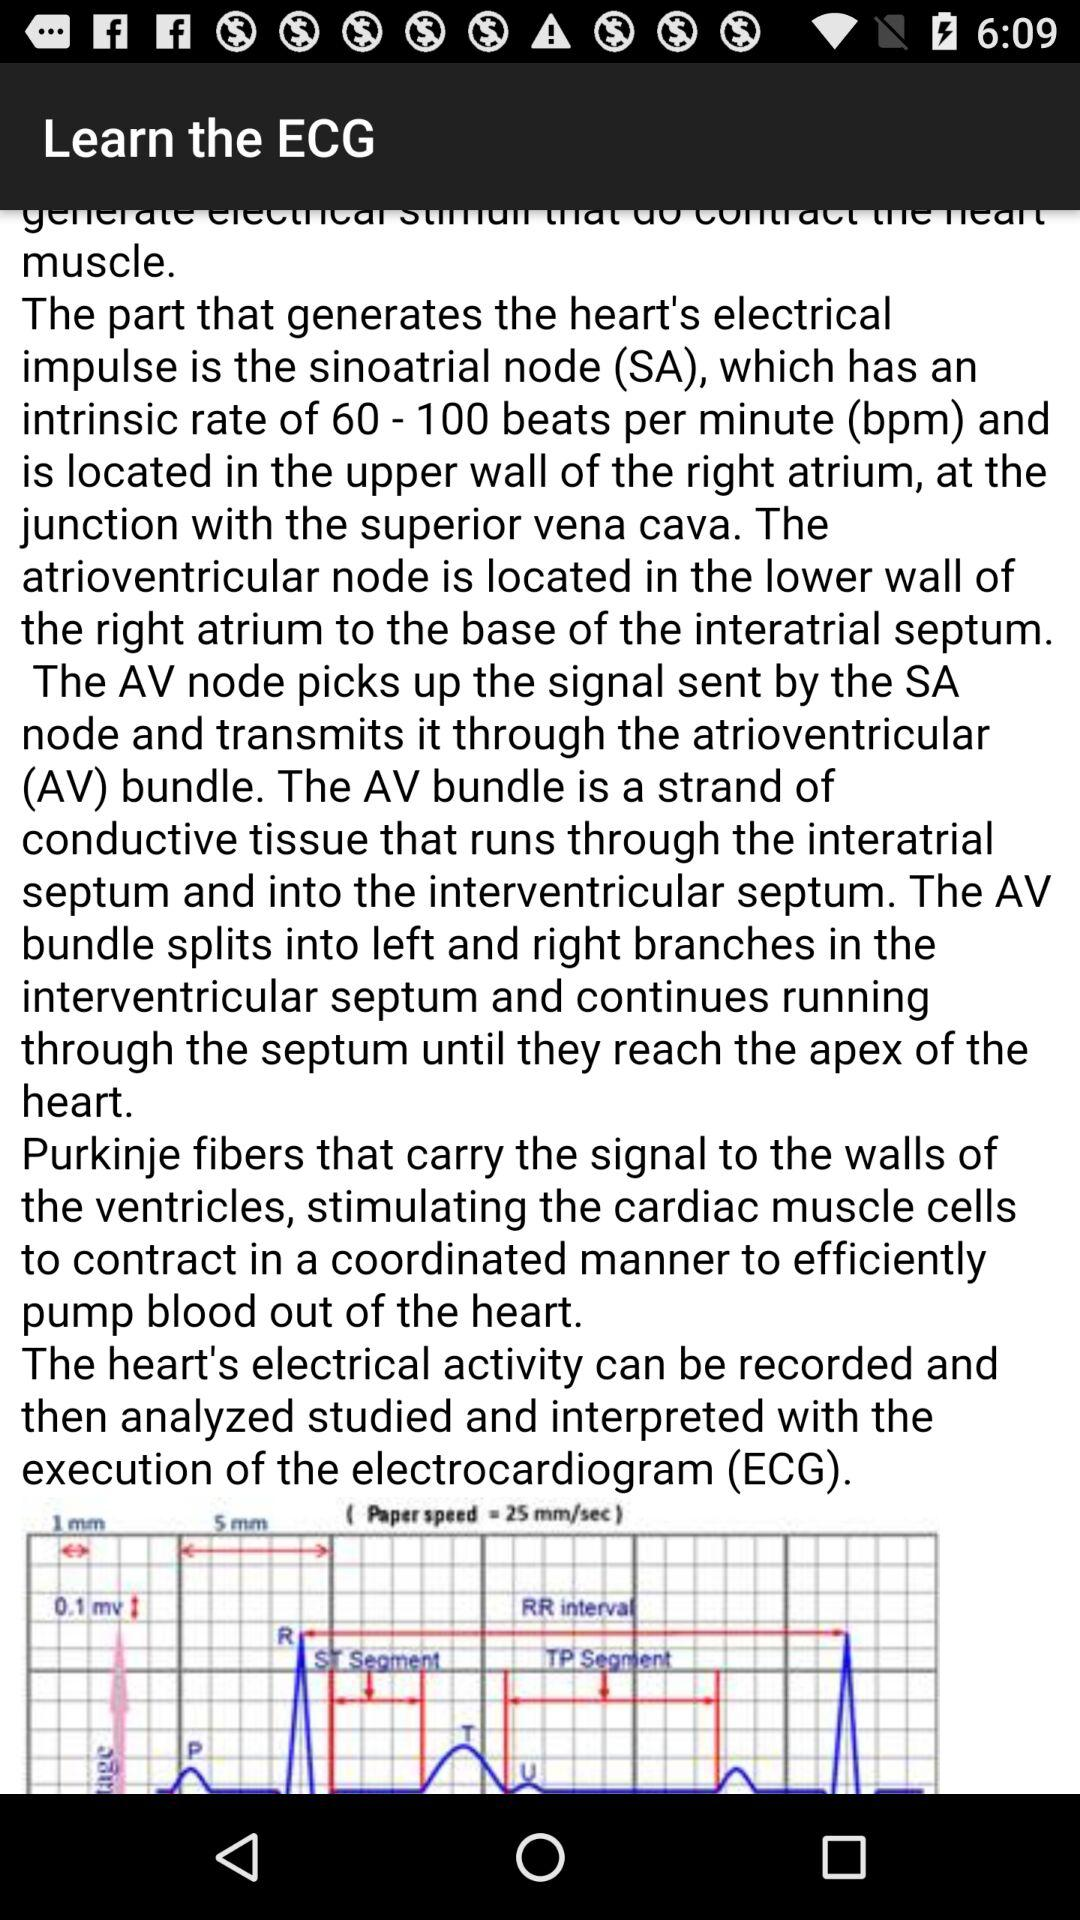What is the version of "ECG practical demo"? The version of "ECG practical demo" is 2.84. 